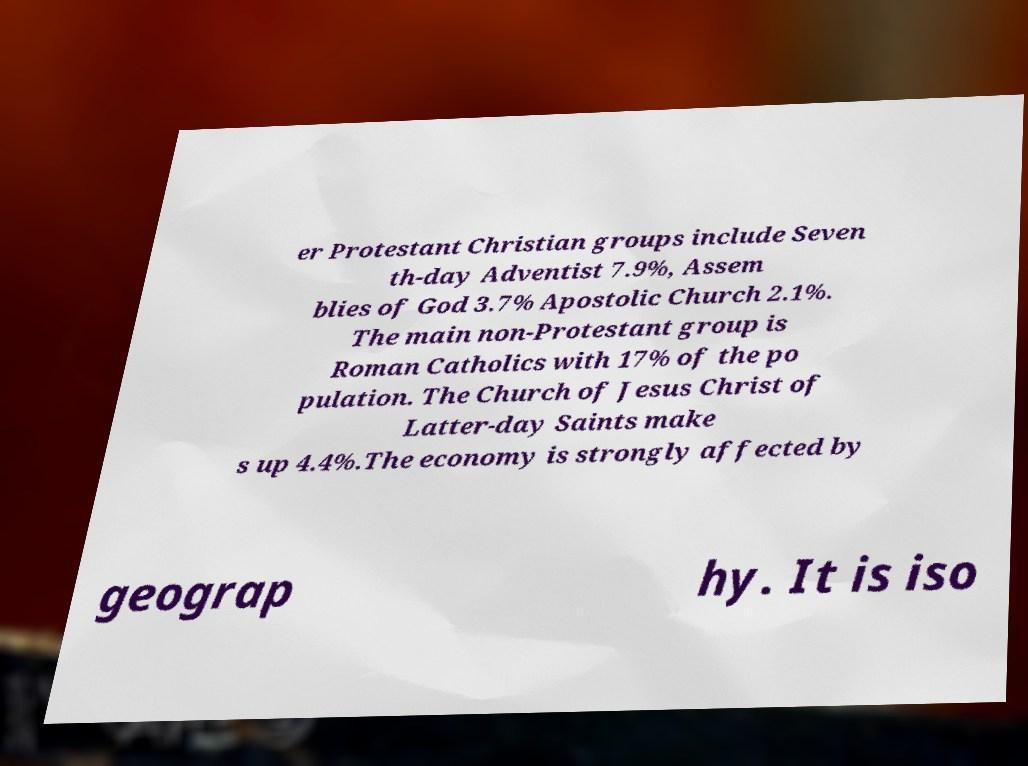I need the written content from this picture converted into text. Can you do that? er Protestant Christian groups include Seven th-day Adventist 7.9%, Assem blies of God 3.7% Apostolic Church 2.1%. The main non-Protestant group is Roman Catholics with 17% of the po pulation. The Church of Jesus Christ of Latter-day Saints make s up 4.4%.The economy is strongly affected by geograp hy. It is iso 